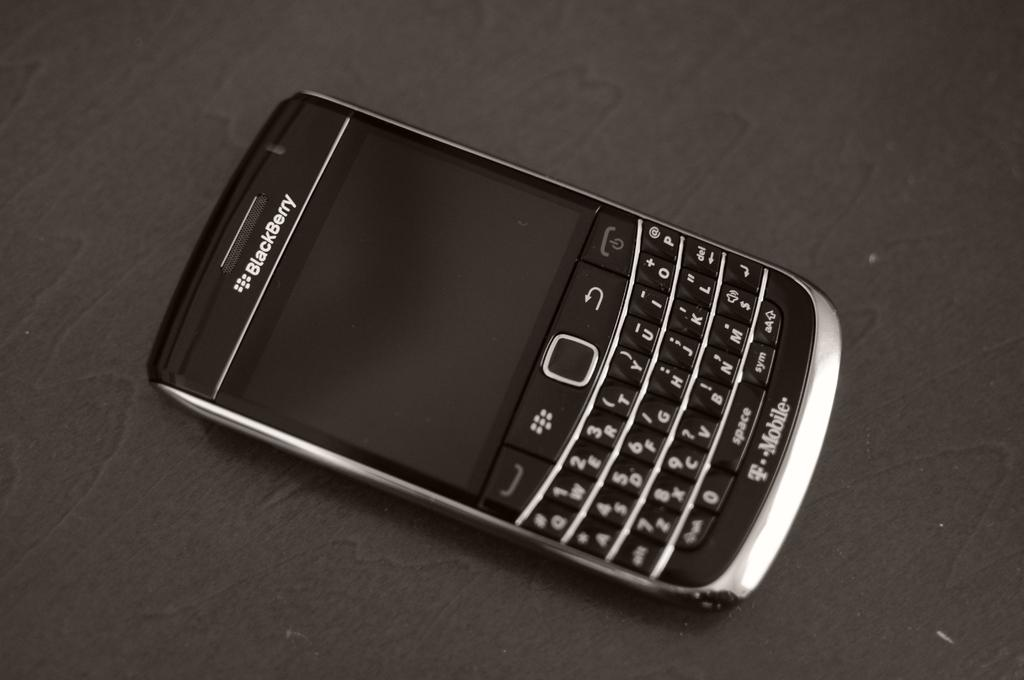<image>
Relay a brief, clear account of the picture shown. a blackberry phone on a table but its not on or powered 